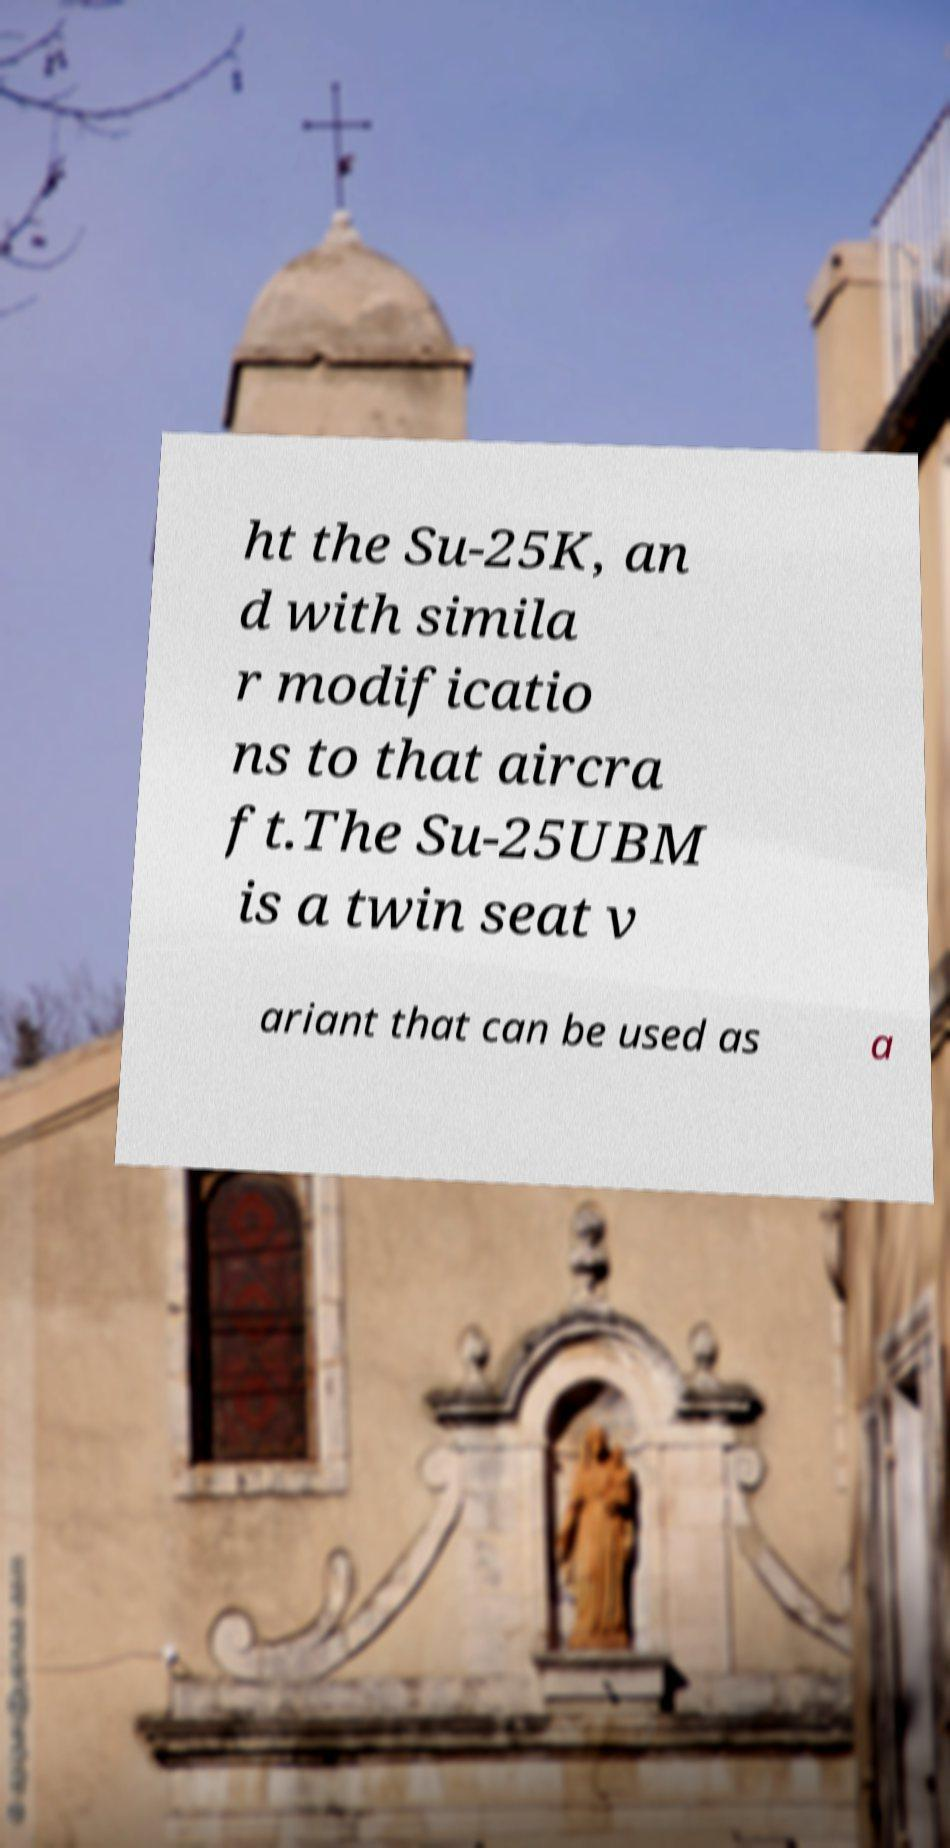Can you read and provide the text displayed in the image?This photo seems to have some interesting text. Can you extract and type it out for me? ht the Su-25K, an d with simila r modificatio ns to that aircra ft.The Su-25UBM is a twin seat v ariant that can be used as a 